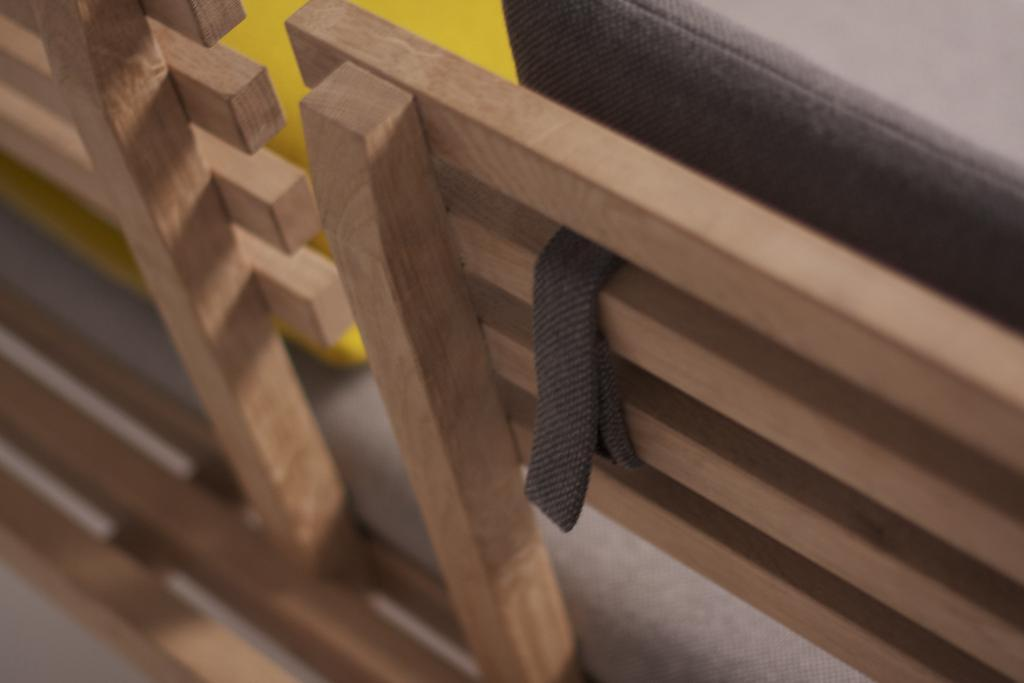What type of furniture is present in the image? There is a wooden bench in the image. Can you describe the objects in the top right corner of the image? There is an object in black color in the top right corner of the image, and there is an object in yellow color beside the black object. What is the condition of the bottom part of the image? The bottom part of the image is blurred. What type of pollution is depicted in the image? There is no depiction of pollution in the image; it features a wooden bench, black and yellow objects, and a blurred bottom part. What decision is being made by the objects in the image? There is no decision-making process depicted in the image; it is a static scene with a wooden bench, black and yellow objects, and a blurred bottom part. 